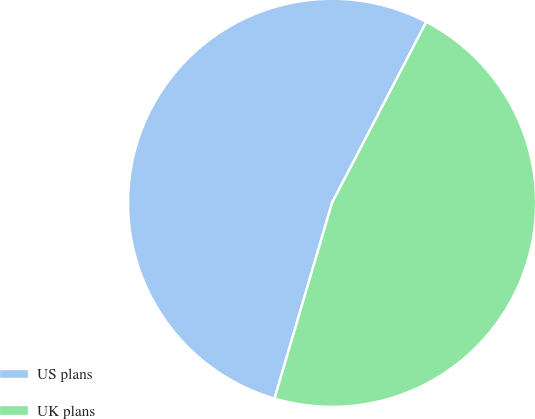Convert chart to OTSL. <chart><loc_0><loc_0><loc_500><loc_500><pie_chart><fcel>US plans<fcel>UK plans<nl><fcel>53.09%<fcel>46.91%<nl></chart> 